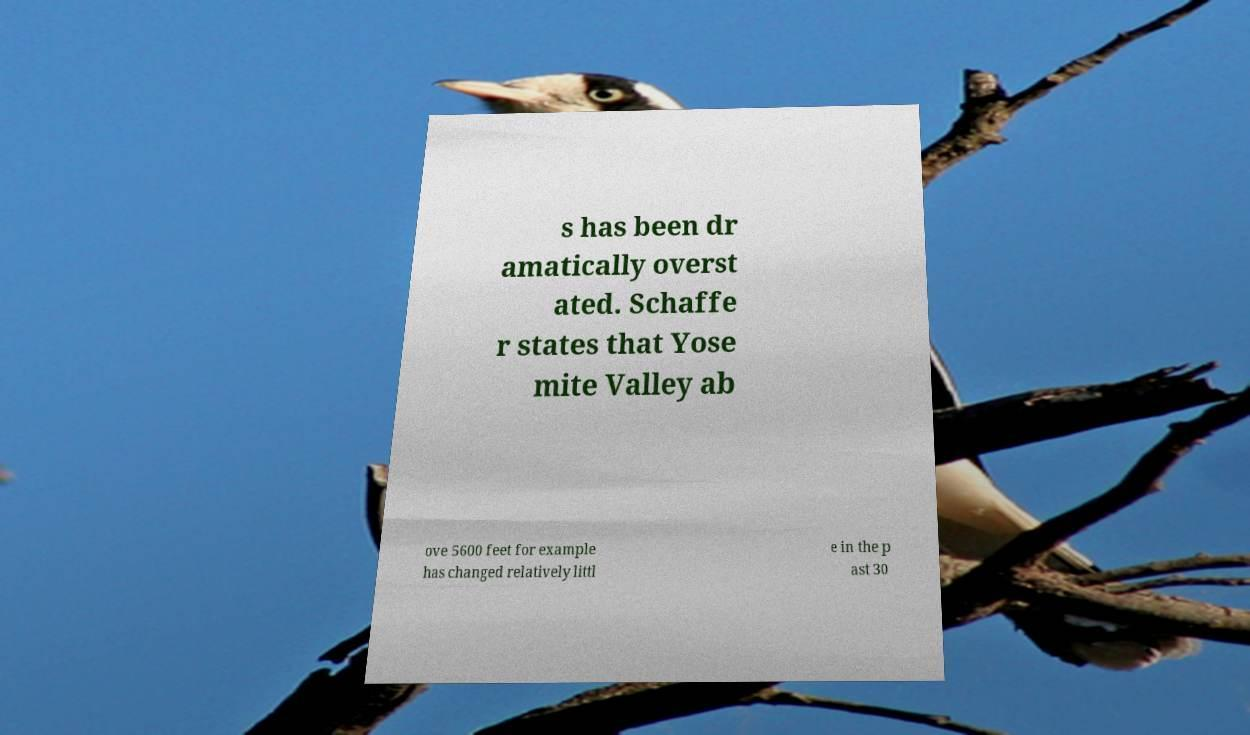Please identify and transcribe the text found in this image. s has been dr amatically overst ated. Schaffe r states that Yose mite Valley ab ove 5600 feet for example has changed relatively littl e in the p ast 30 